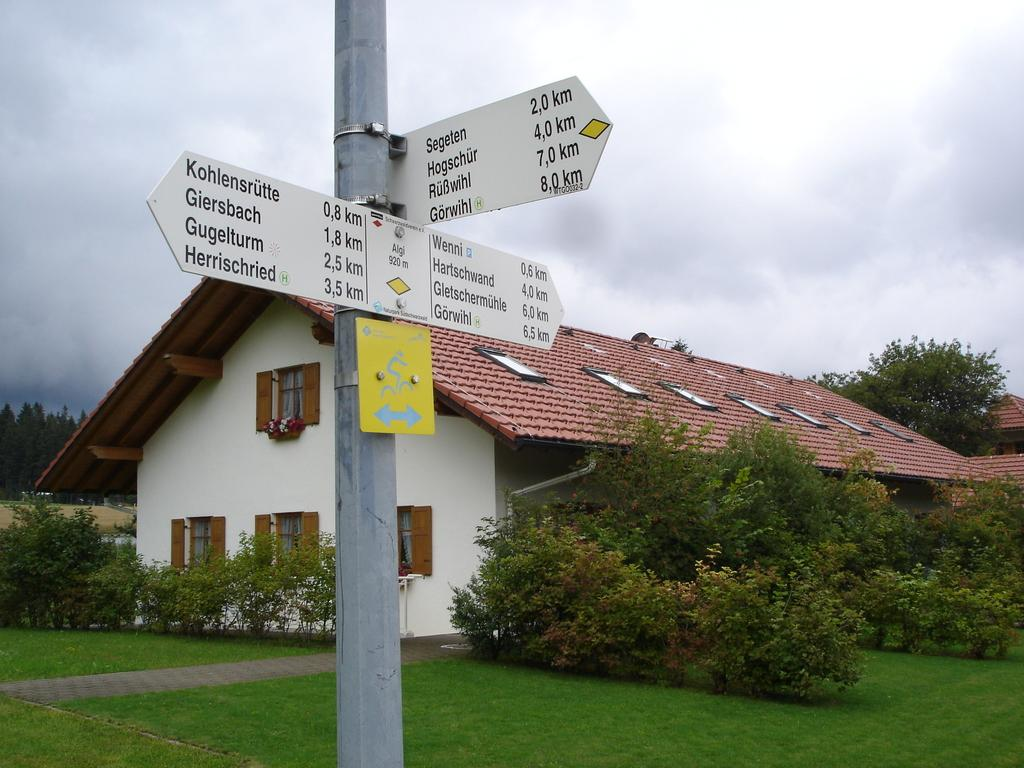<image>
Create a compact narrative representing the image presented. a sign that lists towns and distance and has Gugelturm is 2,5 km 